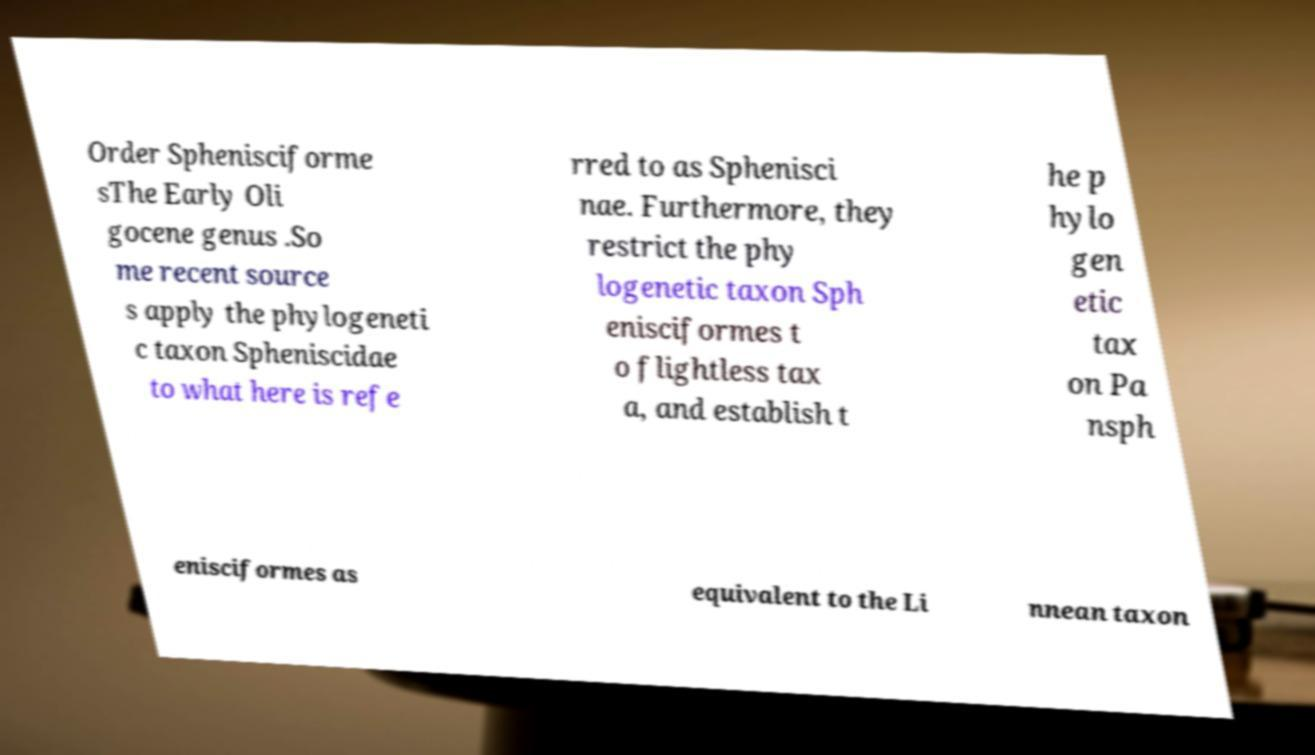Can you read and provide the text displayed in the image?This photo seems to have some interesting text. Can you extract and type it out for me? Order Sphenisciforme sThe Early Oli gocene genus .So me recent source s apply the phylogeneti c taxon Spheniscidae to what here is refe rred to as Sphenisci nae. Furthermore, they restrict the phy logenetic taxon Sph enisciformes t o flightless tax a, and establish t he p hylo gen etic tax on Pa nsph enisciformes as equivalent to the Li nnean taxon 